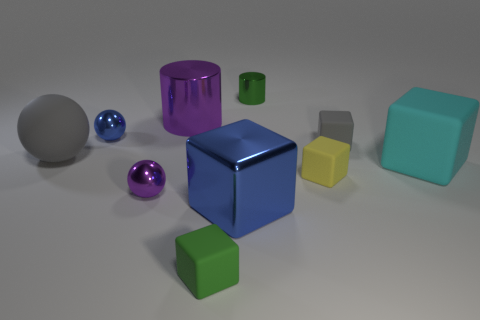How many objects are red rubber cylinders or green rubber objects?
Make the answer very short. 1. What number of rubber objects have the same color as the large rubber ball?
Provide a succinct answer. 1. What shape is the blue shiny thing that is the same size as the cyan matte thing?
Your answer should be compact. Cube. Is there a yellow object that has the same shape as the large blue shiny object?
Make the answer very short. Yes. What number of small balls have the same material as the small gray cube?
Your answer should be very brief. 0. Does the big cube behind the large blue thing have the same material as the purple sphere?
Your response must be concise. No. Are there more big cubes that are in front of the purple cylinder than cyan blocks behind the small blue metallic sphere?
Offer a very short reply. Yes. There is a purple thing that is the same size as the shiny cube; what is it made of?
Offer a very short reply. Metal. What number of other objects are there of the same material as the large gray object?
Offer a very short reply. 4. There is a large blue object that is left of the yellow matte block; does it have the same shape as the green thing in front of the purple cylinder?
Your answer should be compact. Yes. 